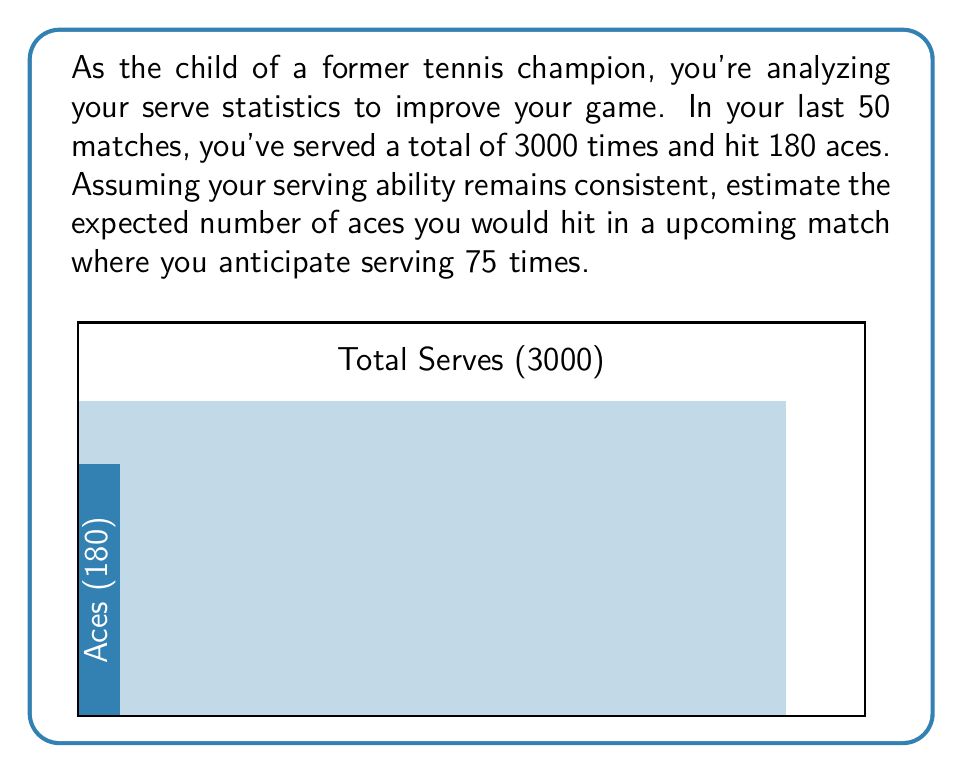Solve this math problem. Let's approach this step-by-step:

1) First, we need to calculate the probability of hitting an ace on a single serve. We can do this by dividing the total number of aces by the total number of serves:

   $P(\text{ace}) = \frac{\text{Number of aces}}{\text{Total serves}} = \frac{180}{3000} = 0.06$ or 6%

2) Now that we know the probability of an ace on a single serve, we can use this to calculate the expected number of aces in the upcoming match.

3) The expected value of a binomial distribution is given by the formula:

   $E(X) = np$

   Where:
   $n$ is the number of trials (in this case, the number of serves)
   $p$ is the probability of success on each trial (in this case, the probability of an ace)

4) In our scenario:
   $n = 75$ (anticipated number of serves in the upcoming match)
   $p = 0.06$ (probability of an ace per serve)

5) Plugging these values into our formula:

   $E(X) = 75 \times 0.06 = 4.5$

Therefore, the expected number of aces in the upcoming match is 4.5.
Answer: 4.5 aces 